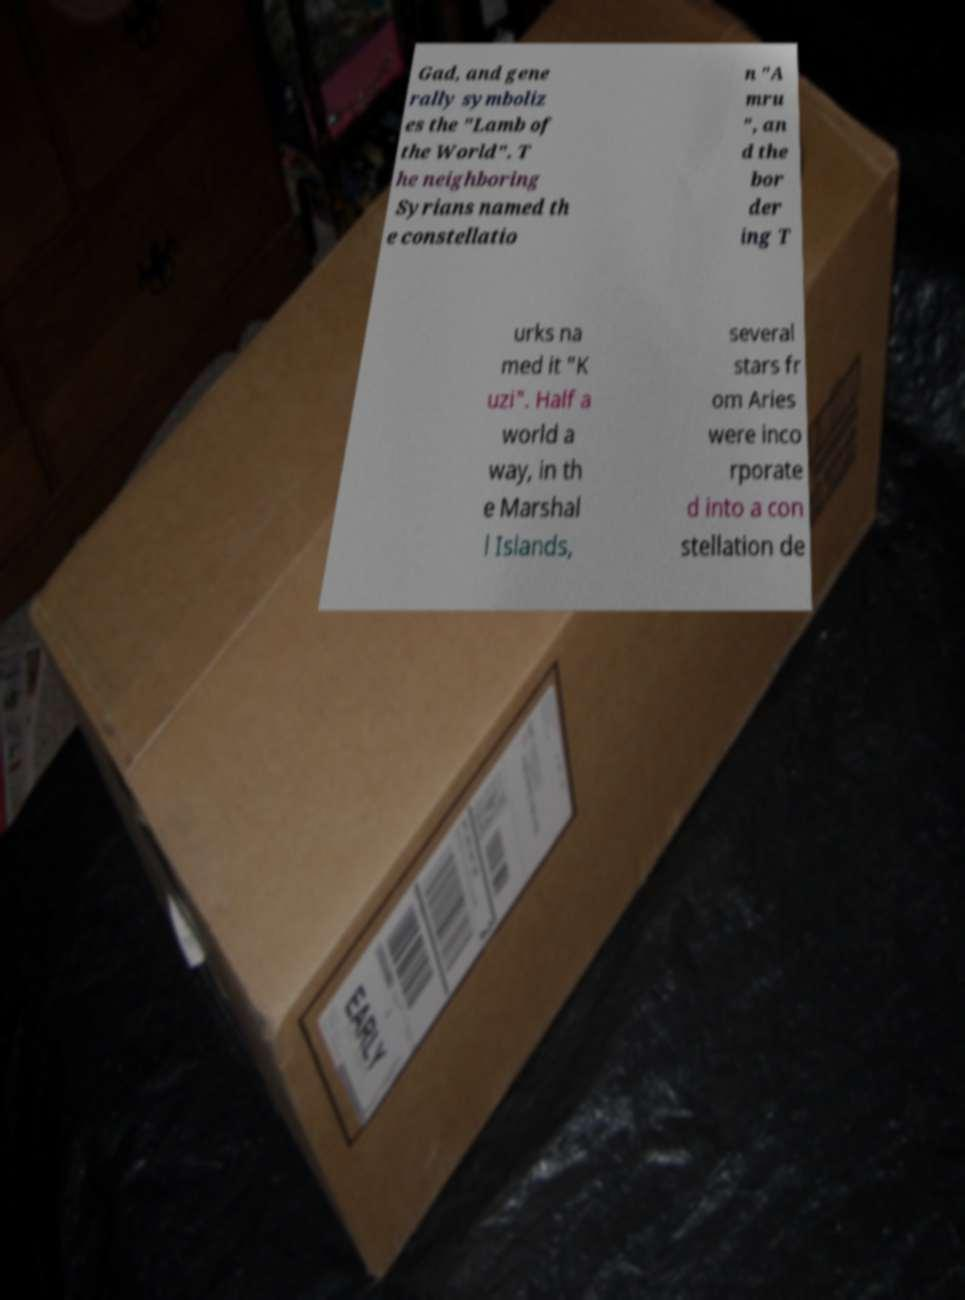Can you accurately transcribe the text from the provided image for me? Gad, and gene rally symboliz es the "Lamb of the World". T he neighboring Syrians named th e constellatio n "A mru ", an d the bor der ing T urks na med it "K uzi". Half a world a way, in th e Marshal l Islands, several stars fr om Aries were inco rporate d into a con stellation de 